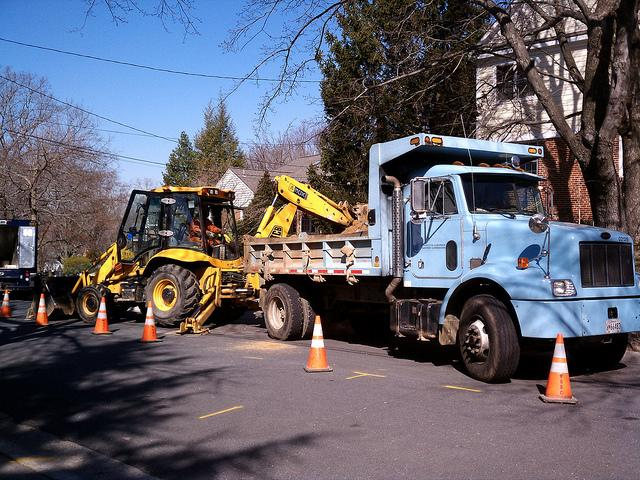What is near the blue truck? cones 